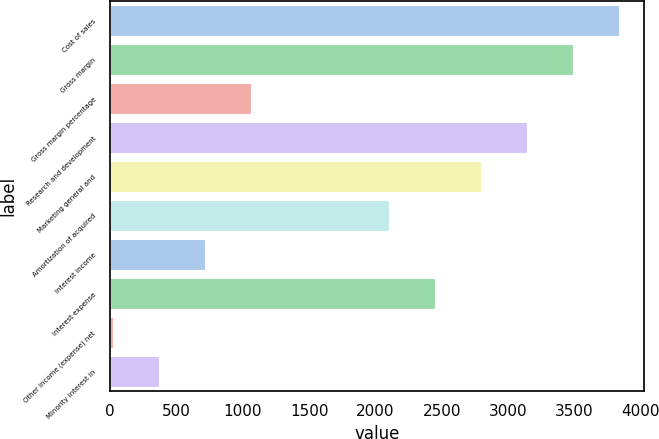Convert chart to OTSL. <chart><loc_0><loc_0><loc_500><loc_500><bar_chart><fcel>Cost of sales<fcel>Gross margin<fcel>Gross margin percentage<fcel>Research and development<fcel>Marketing general and<fcel>Amortization of acquired<fcel>Interest income<fcel>Interest expense<fcel>Other income (expense) net<fcel>Minority interest in<nl><fcel>3834.6<fcel>3488<fcel>1061.8<fcel>3141.4<fcel>2794.8<fcel>2101.6<fcel>715.2<fcel>2448.2<fcel>22<fcel>368.6<nl></chart> 